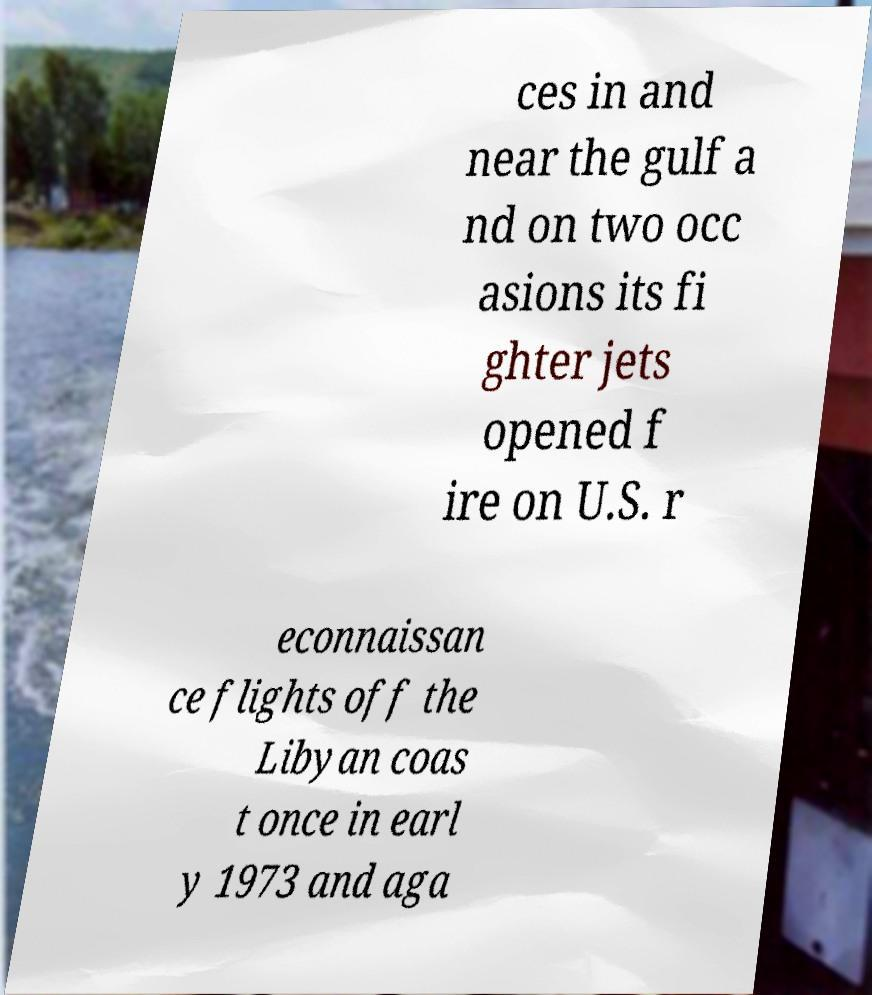Can you read and provide the text displayed in the image?This photo seems to have some interesting text. Can you extract and type it out for me? ces in and near the gulf a nd on two occ asions its fi ghter jets opened f ire on U.S. r econnaissan ce flights off the Libyan coas t once in earl y 1973 and aga 